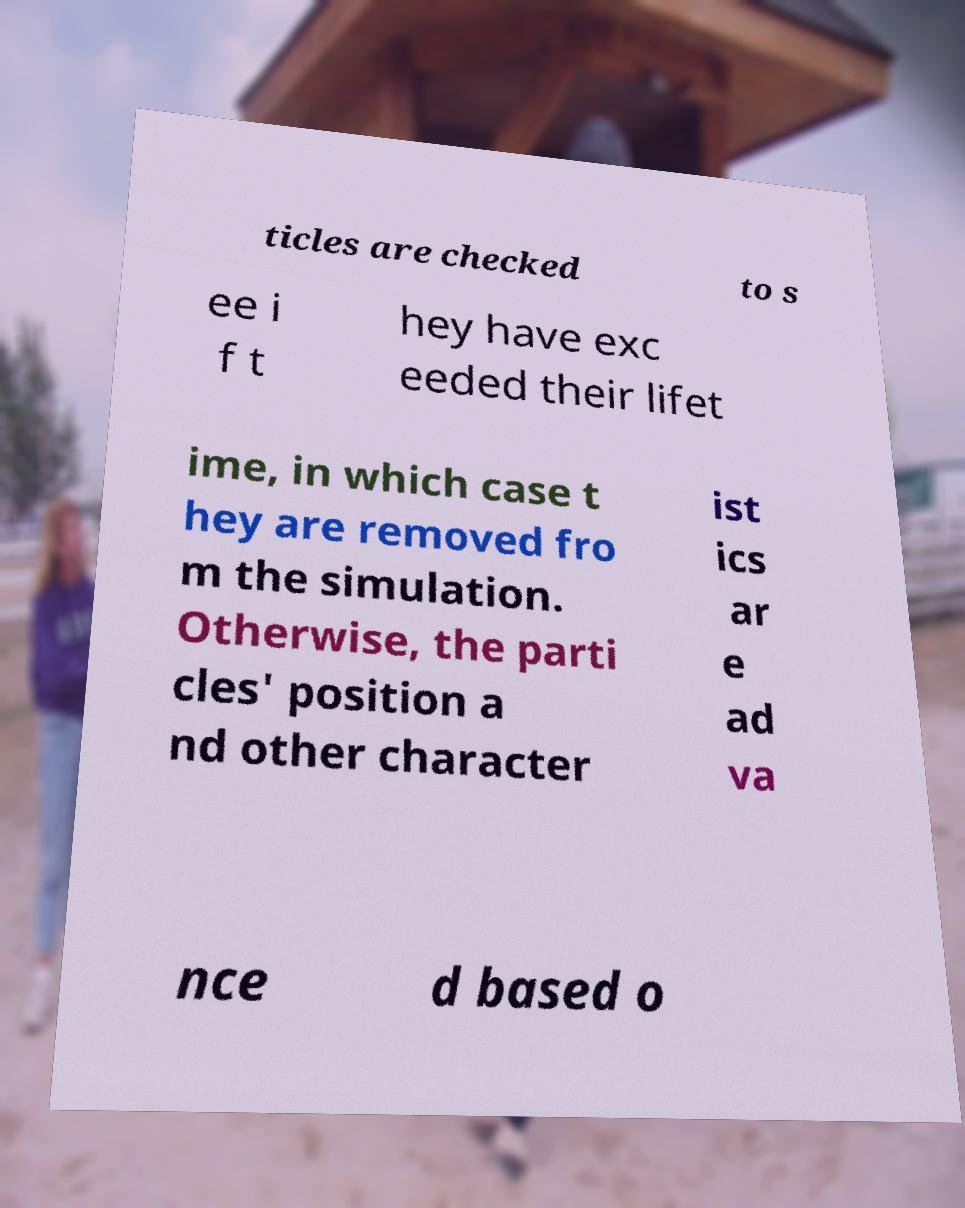For documentation purposes, I need the text within this image transcribed. Could you provide that? ticles are checked to s ee i f t hey have exc eeded their lifet ime, in which case t hey are removed fro m the simulation. Otherwise, the parti cles' position a nd other character ist ics ar e ad va nce d based o 